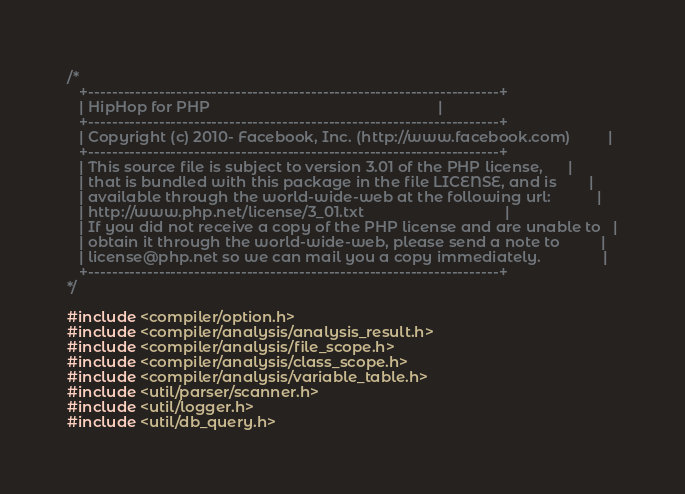Convert code to text. <code><loc_0><loc_0><loc_500><loc_500><_C++_>/*
   +----------------------------------------------------------------------+
   | HipHop for PHP                                                       |
   +----------------------------------------------------------------------+
   | Copyright (c) 2010- Facebook, Inc. (http://www.facebook.com)         |
   +----------------------------------------------------------------------+
   | This source file is subject to version 3.01 of the PHP license,      |
   | that is bundled with this package in the file LICENSE, and is        |
   | available through the world-wide-web at the following url:           |
   | http://www.php.net/license/3_01.txt                                  |
   | If you did not receive a copy of the PHP license and are unable to   |
   | obtain it through the world-wide-web, please send a note to          |
   | license@php.net so we can mail you a copy immediately.               |
   +----------------------------------------------------------------------+
*/

#include <compiler/option.h>
#include <compiler/analysis/analysis_result.h>
#include <compiler/analysis/file_scope.h>
#include <compiler/analysis/class_scope.h>
#include <compiler/analysis/variable_table.h>
#include <util/parser/scanner.h>
#include <util/logger.h>
#include <util/db_query.h></code> 